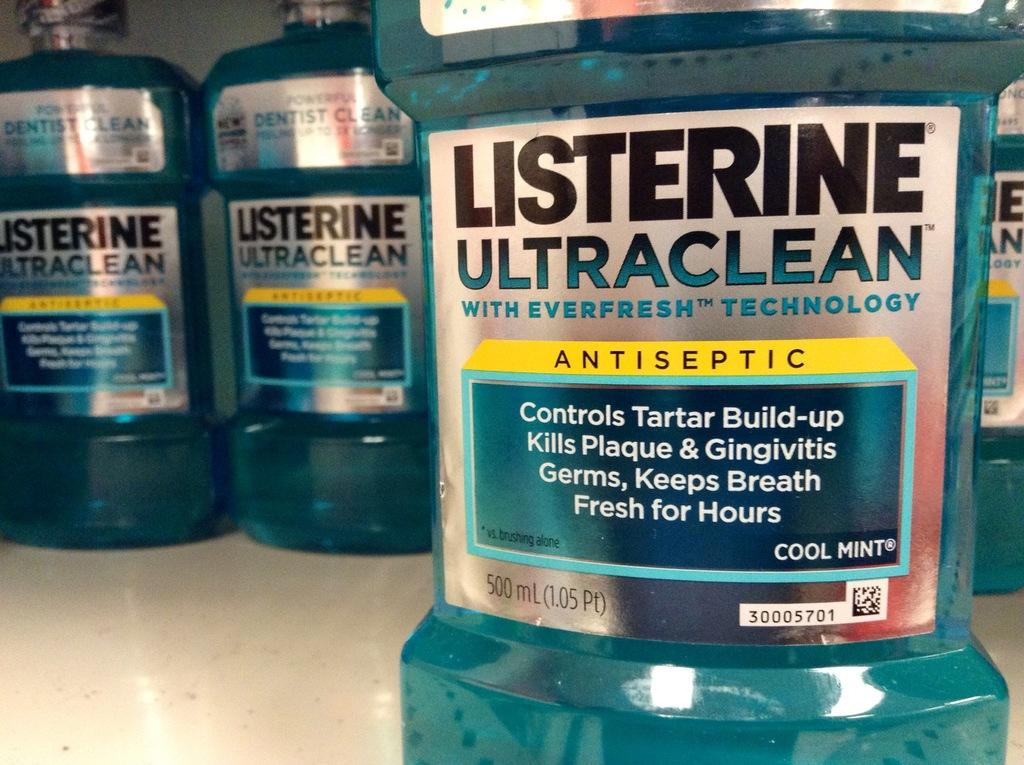<image>
Create a compact narrative representing the image presented. A bottle of Listerine mouthwash which is cool mint flavoured. 